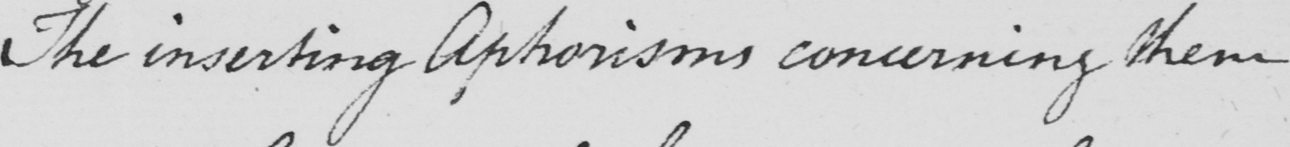Can you read and transcribe this handwriting? The inserting Aphorisms concerning them 